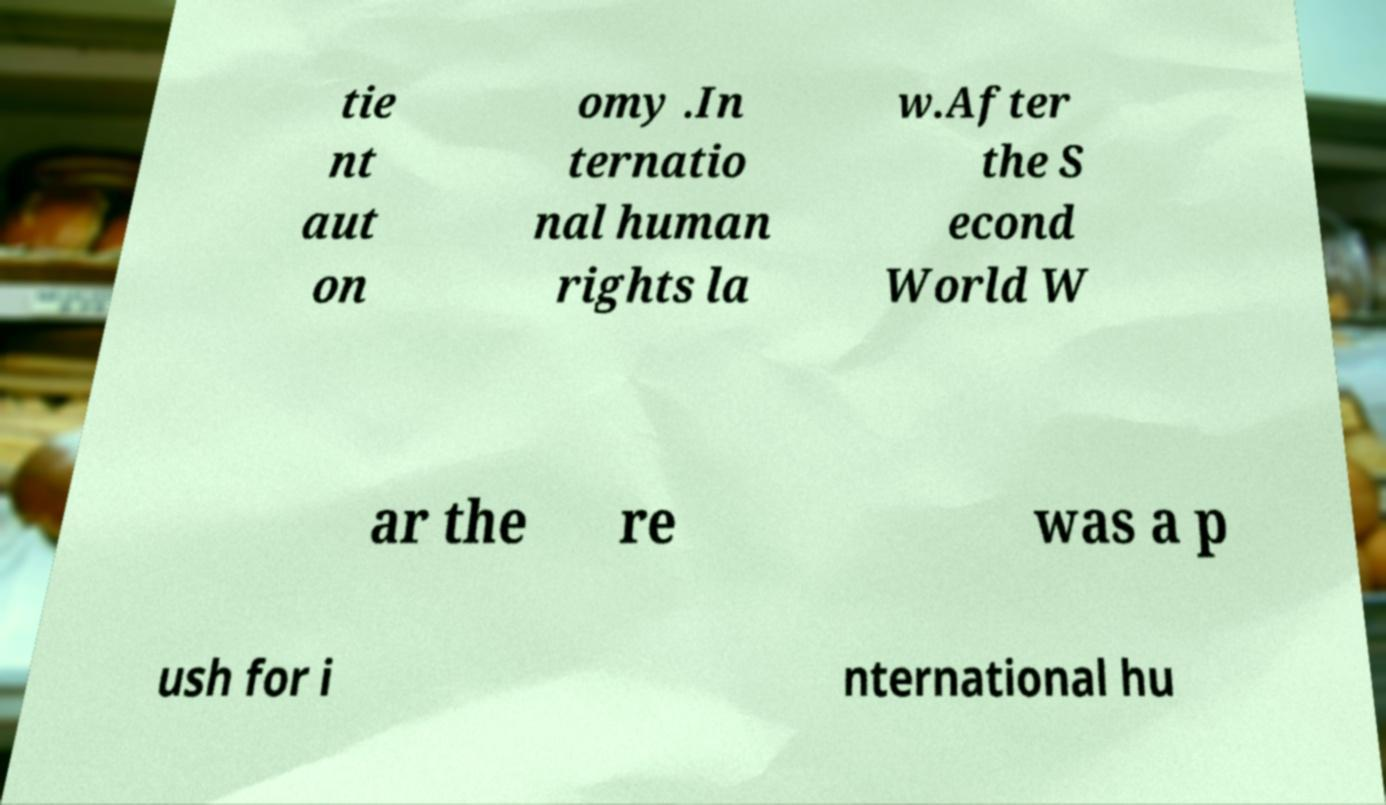Please identify and transcribe the text found in this image. tie nt aut on omy .In ternatio nal human rights la w.After the S econd World W ar the re was a p ush for i nternational hu 